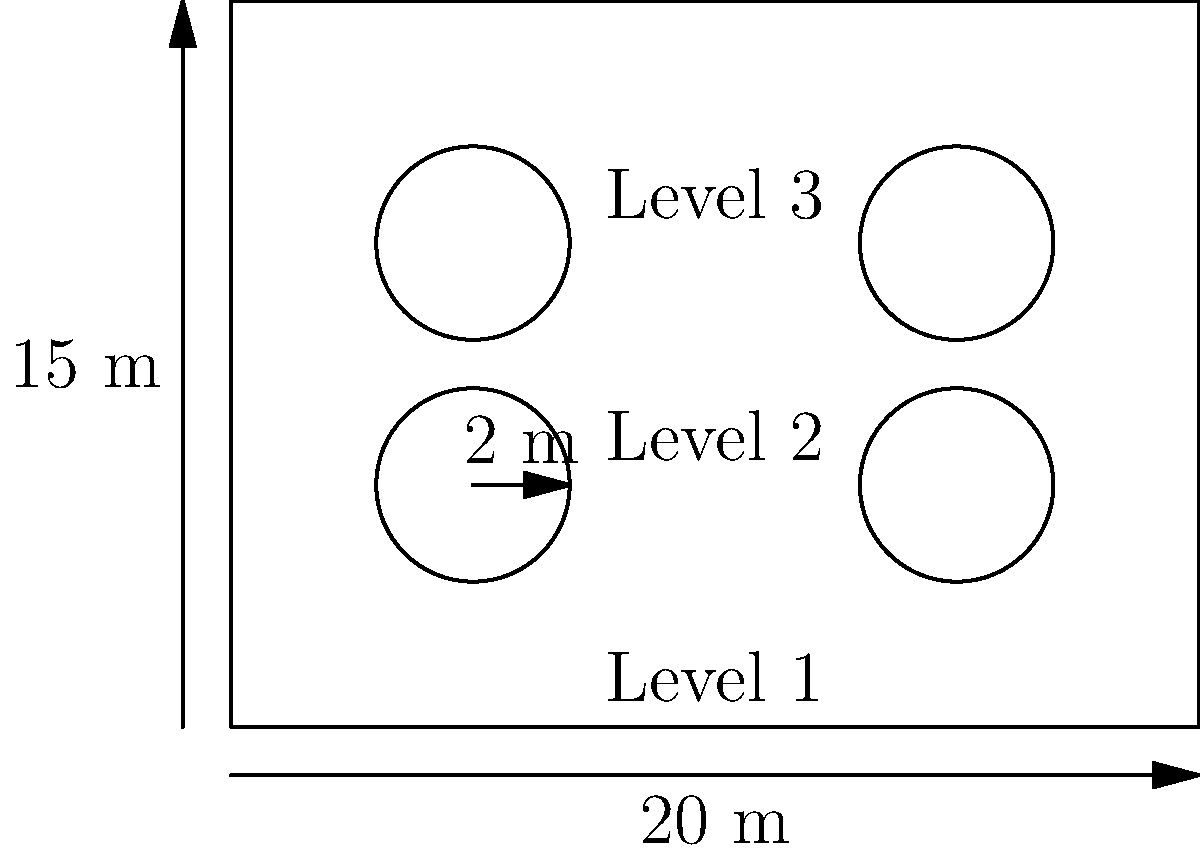A multi-level parking structure has three rectangular floors, each measuring 20 m by 15 m. Four circular ramps, each with a radius of 2 m, connect the floors. Estimate the total perimeter of the structure, including the outer edges of all floors and the circumferences of all ramps. Assume the structure has solid walls between floors, and the ramps are equally spaced as shown in the diagram. How does this design impact the structure's response to dynamic loads compared to a standard rectangular design? To estimate the total perimeter, we'll follow these steps:

1) Calculate the perimeter of one rectangular floor:
   $$P_{floor} = 2(20 + 15) = 70 \text{ m}$$

2) Calculate the perimeter for all three floors:
   $$P_{all floors} = 3 \times 70 = 210 \text{ m}$$

3) Calculate the circumference of one circular ramp:
   $$C_{ramp} = 2\pi r = 2\pi(2) = 4\pi \text{ m}$$

4) Calculate the total circumference for all four ramps:
   $$C_{all ramps} = 4 \times 4\pi = 16\pi \text{ m}$$

5) Sum the perimeters of the floors and ramps:
   $$P_{total} = 210 + 16\pi \approx 260.27 \text{ m}$$

Regarding dynamic load analysis:

1) The circular ramps introduce curved elements, which can help distribute loads more evenly compared to sharp corners in a standard rectangular design.

2) The ramps create a more complex geometry, potentially increasing the structure's natural frequency and altering its response to dynamic loads.

3) The circular elements may provide better resistance to torsional forces induced by dynamic loads, especially during events like earthquakes.

4) The multi-level design with interconnecting ramps creates a more integrated structure, potentially improving overall stability under dynamic loading conditions.

5) However, the openings for the ramps reduce the floor diaphragm stiffness, which could affect the structure's behavior under lateral loads.

This design requires more sophisticated dynamic load analysis compared to a simple rectangular structure, but it may offer improved performance in certain loading scenarios.
Answer: Total perimeter ≈ 260.27 m. The circular ramps alter dynamic load response by distributing forces more evenly, potentially increasing natural frequency, improving torsional resistance, and creating a more integrated structure, but may reduce floor diaphragm stiffness. 